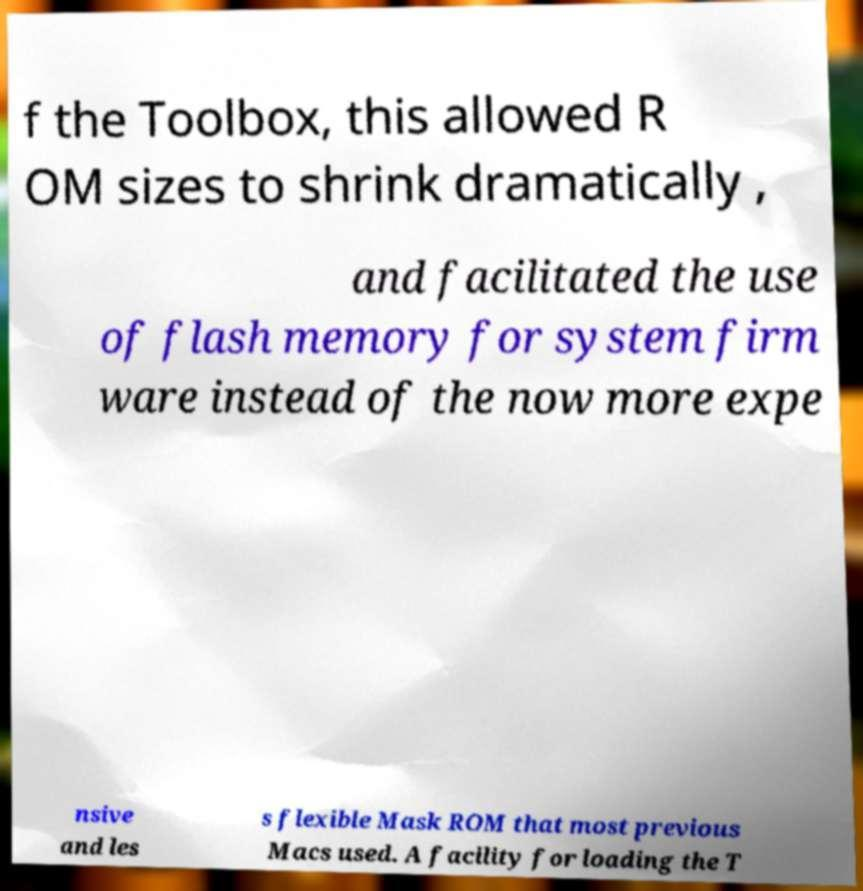What messages or text are displayed in this image? I need them in a readable, typed format. f the Toolbox, this allowed R OM sizes to shrink dramatically , and facilitated the use of flash memory for system firm ware instead of the now more expe nsive and les s flexible Mask ROM that most previous Macs used. A facility for loading the T 